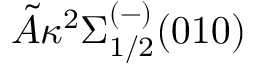<formula> <loc_0><loc_0><loc_500><loc_500>\tilde { A } ^ { 2 } \Sigma _ { 1 / 2 } ^ { ( - ) } ( 0 1 0 )</formula> 